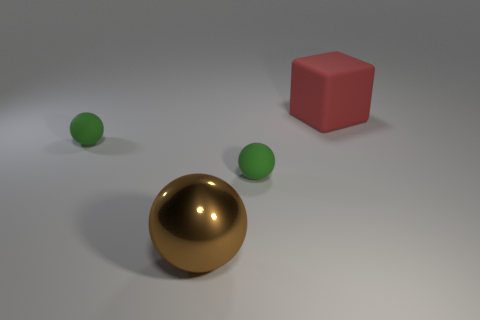Is there anything else that is the same color as the large cube?
Your answer should be compact. No. What number of red things are blocks or tiny metal cylinders?
Offer a very short reply. 1. Are there fewer cubes on the left side of the brown metal ball than things?
Give a very brief answer. Yes. What number of brown objects are to the left of the green thing that is left of the brown thing?
Keep it short and to the point. 0. How many other things are the same size as the red matte block?
Give a very brief answer. 1. How many objects are brown spheres or big things that are behind the large brown ball?
Your response must be concise. 2. Is the number of red objects less than the number of tiny matte balls?
Provide a short and direct response. Yes. There is a large thing that is left of the red matte object to the right of the brown object; what color is it?
Offer a very short reply. Brown. What number of shiny objects are either large blue spheres or small balls?
Keep it short and to the point. 0. Do the small ball that is on the right side of the brown object and the small green object left of the large brown metallic object have the same material?
Make the answer very short. Yes. 